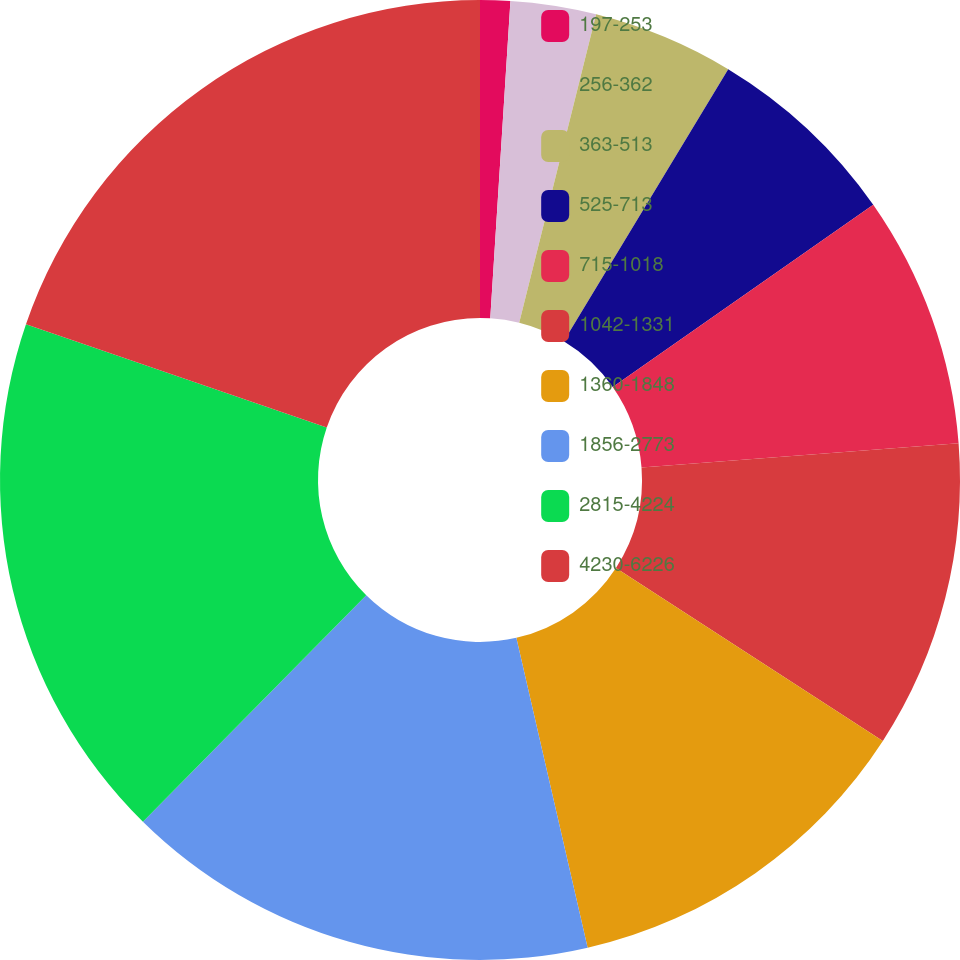Convert chart to OTSL. <chart><loc_0><loc_0><loc_500><loc_500><pie_chart><fcel>197-253<fcel>256-362<fcel>363-513<fcel>525-713<fcel>715-1018<fcel>1042-1331<fcel>1360-1848<fcel>1856-2773<fcel>2815-4224<fcel>4230-6226<nl><fcel>1.01%<fcel>2.88%<fcel>4.76%<fcel>6.63%<fcel>8.5%<fcel>10.37%<fcel>12.25%<fcel>15.99%<fcel>17.87%<fcel>19.74%<nl></chart> 